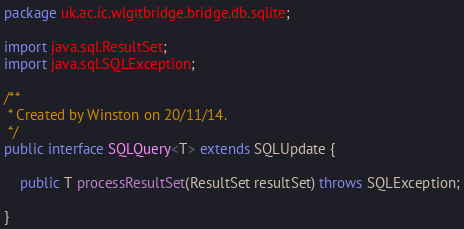Convert code to text. <code><loc_0><loc_0><loc_500><loc_500><_Java_>package uk.ac.ic.wlgitbridge.bridge.db.sqlite;

import java.sql.ResultSet;
import java.sql.SQLException;

/**
 * Created by Winston on 20/11/14.
 */
public interface SQLQuery<T> extends SQLUpdate {

    public T processResultSet(ResultSet resultSet) throws SQLException;

}
</code> 